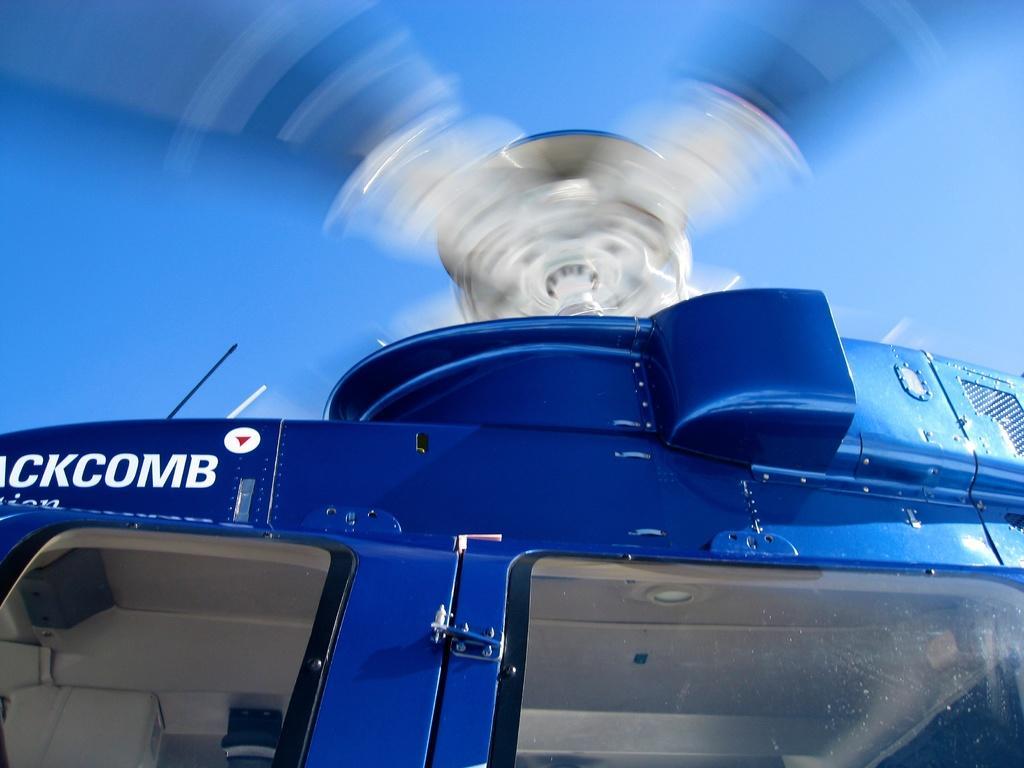Could you give a brief overview of what you see in this image? It is a zoomed in picture of a helicopter. Sky is also visible in this image. 